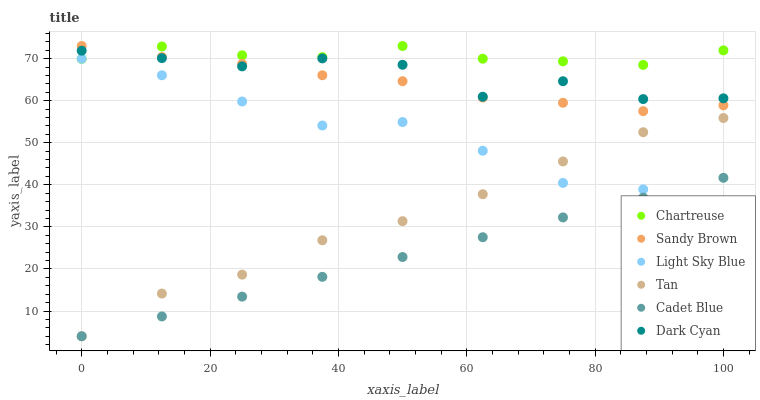Does Cadet Blue have the minimum area under the curve?
Answer yes or no. Yes. Does Chartreuse have the maximum area under the curve?
Answer yes or no. Yes. Does Light Sky Blue have the minimum area under the curve?
Answer yes or no. No. Does Light Sky Blue have the maximum area under the curve?
Answer yes or no. No. Is Cadet Blue the smoothest?
Answer yes or no. Yes. Is Dark Cyan the roughest?
Answer yes or no. Yes. Is Chartreuse the smoothest?
Answer yes or no. No. Is Chartreuse the roughest?
Answer yes or no. No. Does Cadet Blue have the lowest value?
Answer yes or no. Yes. Does Light Sky Blue have the lowest value?
Answer yes or no. No. Does Sandy Brown have the highest value?
Answer yes or no. Yes. Does Light Sky Blue have the highest value?
Answer yes or no. No. Is Light Sky Blue less than Sandy Brown?
Answer yes or no. Yes. Is Dark Cyan greater than Light Sky Blue?
Answer yes or no. Yes. Does Dark Cyan intersect Chartreuse?
Answer yes or no. Yes. Is Dark Cyan less than Chartreuse?
Answer yes or no. No. Is Dark Cyan greater than Chartreuse?
Answer yes or no. No. Does Light Sky Blue intersect Sandy Brown?
Answer yes or no. No. 